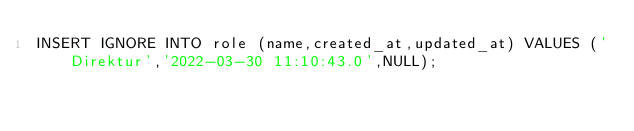<code> <loc_0><loc_0><loc_500><loc_500><_SQL_>INSERT IGNORE INTO role (name,created_at,updated_at) VALUES ('Direktur','2022-03-30 11:10:43.0',NULL);</code> 